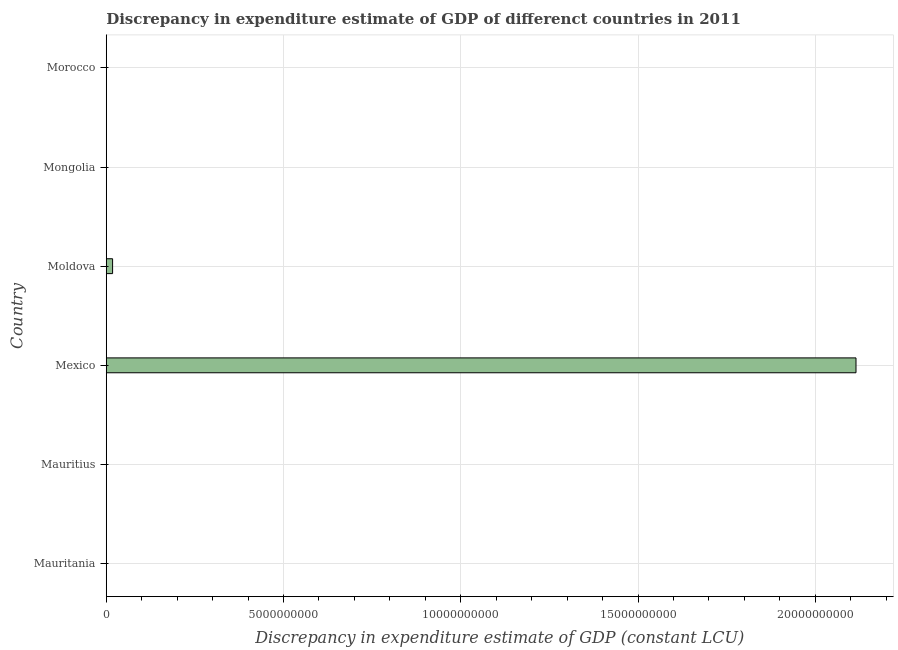Does the graph contain grids?
Provide a succinct answer. Yes. What is the title of the graph?
Provide a short and direct response. Discrepancy in expenditure estimate of GDP of differenct countries in 2011. What is the label or title of the X-axis?
Ensure brevity in your answer.  Discrepancy in expenditure estimate of GDP (constant LCU). What is the label or title of the Y-axis?
Ensure brevity in your answer.  Country. What is the discrepancy in expenditure estimate of gdp in Mauritania?
Provide a succinct answer. 0. Across all countries, what is the maximum discrepancy in expenditure estimate of gdp?
Offer a very short reply. 2.11e+1. What is the sum of the discrepancy in expenditure estimate of gdp?
Keep it short and to the point. 2.13e+1. What is the average discrepancy in expenditure estimate of gdp per country?
Your response must be concise. 3.55e+09. In how many countries, is the discrepancy in expenditure estimate of gdp greater than 7000000000 LCU?
Give a very brief answer. 1. What is the difference between the highest and the lowest discrepancy in expenditure estimate of gdp?
Ensure brevity in your answer.  2.11e+1. How many countries are there in the graph?
Give a very brief answer. 6. What is the Discrepancy in expenditure estimate of GDP (constant LCU) of Mauritania?
Give a very brief answer. 0. What is the Discrepancy in expenditure estimate of GDP (constant LCU) in Mexico?
Your answer should be very brief. 2.11e+1. What is the Discrepancy in expenditure estimate of GDP (constant LCU) in Moldova?
Your response must be concise. 1.79e+08. What is the Discrepancy in expenditure estimate of GDP (constant LCU) of Morocco?
Your answer should be very brief. 0. What is the difference between the Discrepancy in expenditure estimate of GDP (constant LCU) in Mexico and Moldova?
Offer a terse response. 2.10e+1. What is the ratio of the Discrepancy in expenditure estimate of GDP (constant LCU) in Mexico to that in Moldova?
Keep it short and to the point. 118.27. 